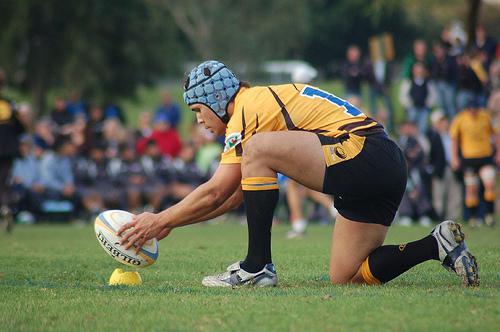Question: where is it played?
Choices:
A. On a court.
B. On the lawn.
C. In the gym.
D. On a field.
Answer with the letter. Answer: D Question: who wears head protection?
Choices:
A. Some players.
B. Welders.
C. Cyclists.
D. Football players.
Answer with the letter. Answer: A Question: how many players on a team?
Choices:
A. 10 on the field and 5 subs.
B. 9 on the field and 4 subs.
C. 15 on the field and 7 substitutes.
D. 5 on the field and 10 subs.
Answer with the letter. Answer: C Question: what is the game?
Choices:
A. Football.
B. Soccer.
C. Golf.
D. Rugby.
Answer with the letter. Answer: D 